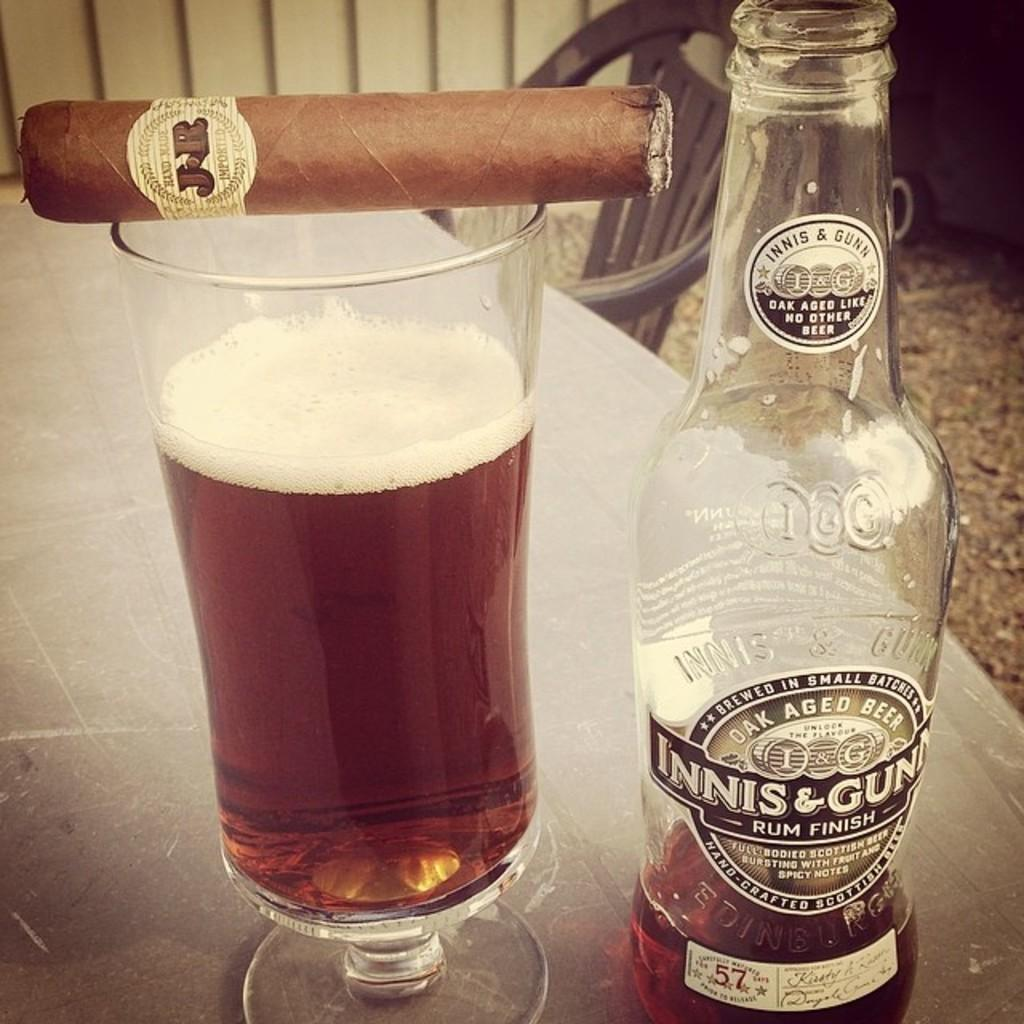What type of alcoholic beverage is present in the image? There is a rum bottle in the image. What is the glass used for in the image? The glass is used to hold a cigar in the image. Where are the objects in the image placed? The objects are kept on a table. What can be seen in the background of the image? There is a chair in the background of the image. What type of hill can be seen in the background of the image? There is no hill present in the image; it features a table with objects and a chair in the background. What is the value of the rum bottle in the image? The value of the rum bottle cannot be determined from the image alone, as it depends on various factors such as the brand, size, and condition of the bottle. 